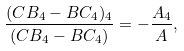Convert formula to latex. <formula><loc_0><loc_0><loc_500><loc_500>\frac { ( C B _ { 4 } - B C _ { 4 } ) _ { 4 } } { ( C B _ { 4 } - B C _ { 4 } ) } = - \frac { A _ { 4 } } { A } ,</formula> 